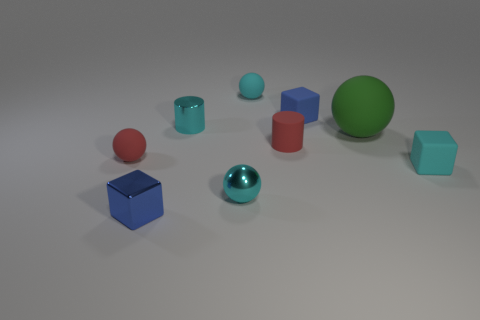Are there fewer matte objects behind the big rubber ball than tiny red rubber things that are on the right side of the blue matte block?
Keep it short and to the point. No. There is a small red object that is left of the small cyan rubber ball; what material is it?
Provide a short and direct response. Rubber. The tiny block that is both on the left side of the big green ball and in front of the small blue rubber object is what color?
Your response must be concise. Blue. What number of other objects are the same color as the large sphere?
Ensure brevity in your answer.  0. There is a small cylinder left of the cyan rubber sphere; what color is it?
Your answer should be very brief. Cyan. Are there any rubber things that have the same size as the metal cylinder?
Give a very brief answer. Yes. What material is the red ball that is the same size as the shiny cylinder?
Your answer should be very brief. Rubber. How many things are small blue blocks that are behind the green thing or cubes that are on the left side of the tiny blue matte block?
Give a very brief answer. 2. Are there any other large rubber objects that have the same shape as the green thing?
Offer a very short reply. No. There is a cylinder that is the same color as the shiny sphere; what is it made of?
Give a very brief answer. Metal. 